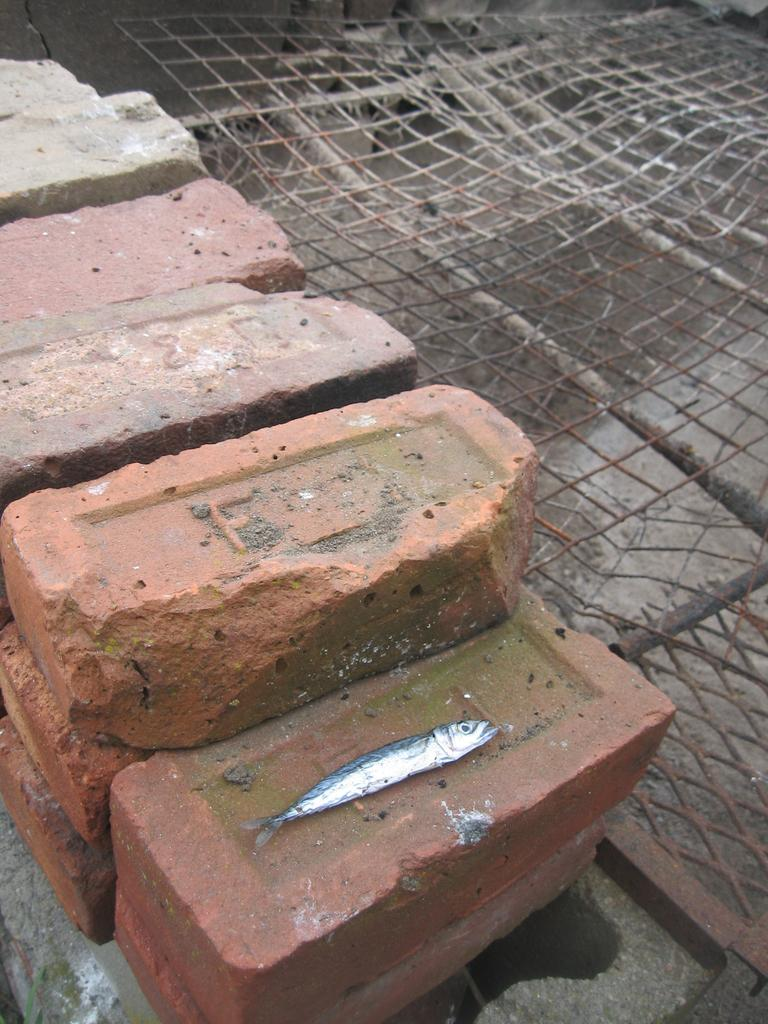What type of material is present in the image? There are bricks in the image. Is there any living creature depicted on the bricks? Yes, there is a fish on one of the bricks. What other object can be seen in the image? There is a metal fence in the image. What type of payment method is accepted by the fish in the image? There is no payment method mentioned or depicted in the image, as it features bricks, a fish, and a metal fence. 